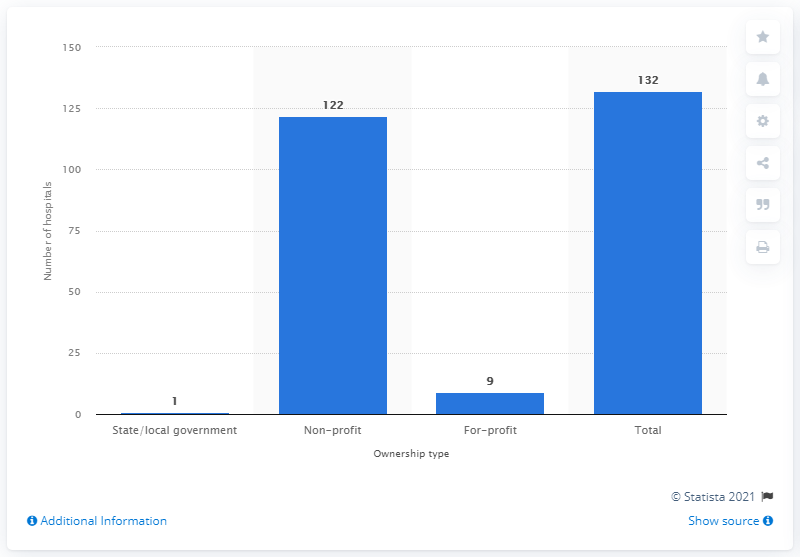Identify some key points in this picture. In 2019, there were 132 hospitals in the state of Wisconsin. 